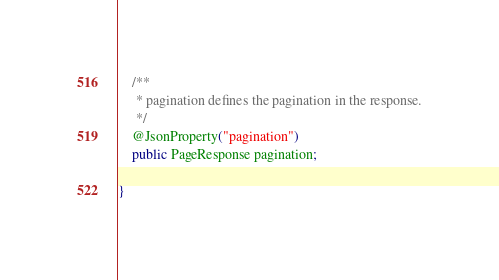<code> <loc_0><loc_0><loc_500><loc_500><_Java_>
    /**
     * pagination defines the pagination in the response.
     */
    @JsonProperty("pagination")
    public PageResponse pagination;

}
</code> 